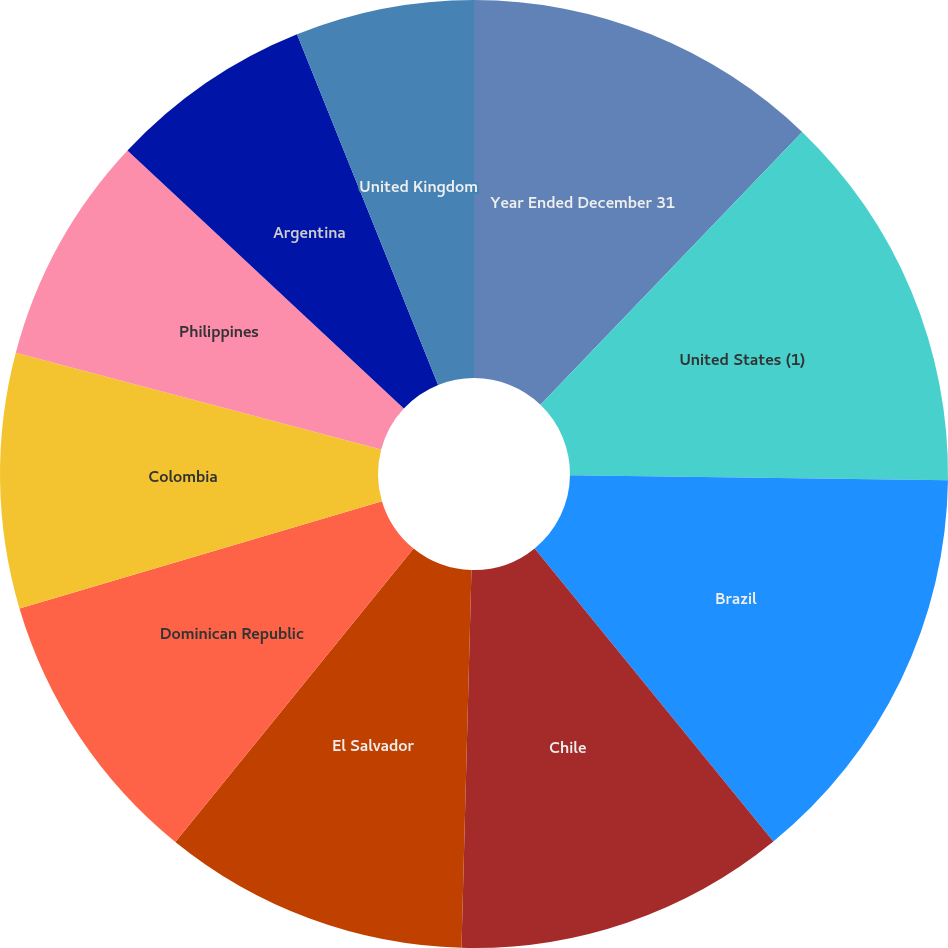Convert chart. <chart><loc_0><loc_0><loc_500><loc_500><pie_chart><fcel>Year Ended December 31<fcel>United States (1)<fcel>Brazil<fcel>Chile<fcel>El Salvador<fcel>Dominican Republic<fcel>Colombia<fcel>Philippines<fcel>Argentina<fcel>United Kingdom<nl><fcel>12.17%<fcel>13.04%<fcel>13.91%<fcel>11.3%<fcel>10.43%<fcel>9.57%<fcel>8.7%<fcel>7.83%<fcel>6.96%<fcel>6.09%<nl></chart> 